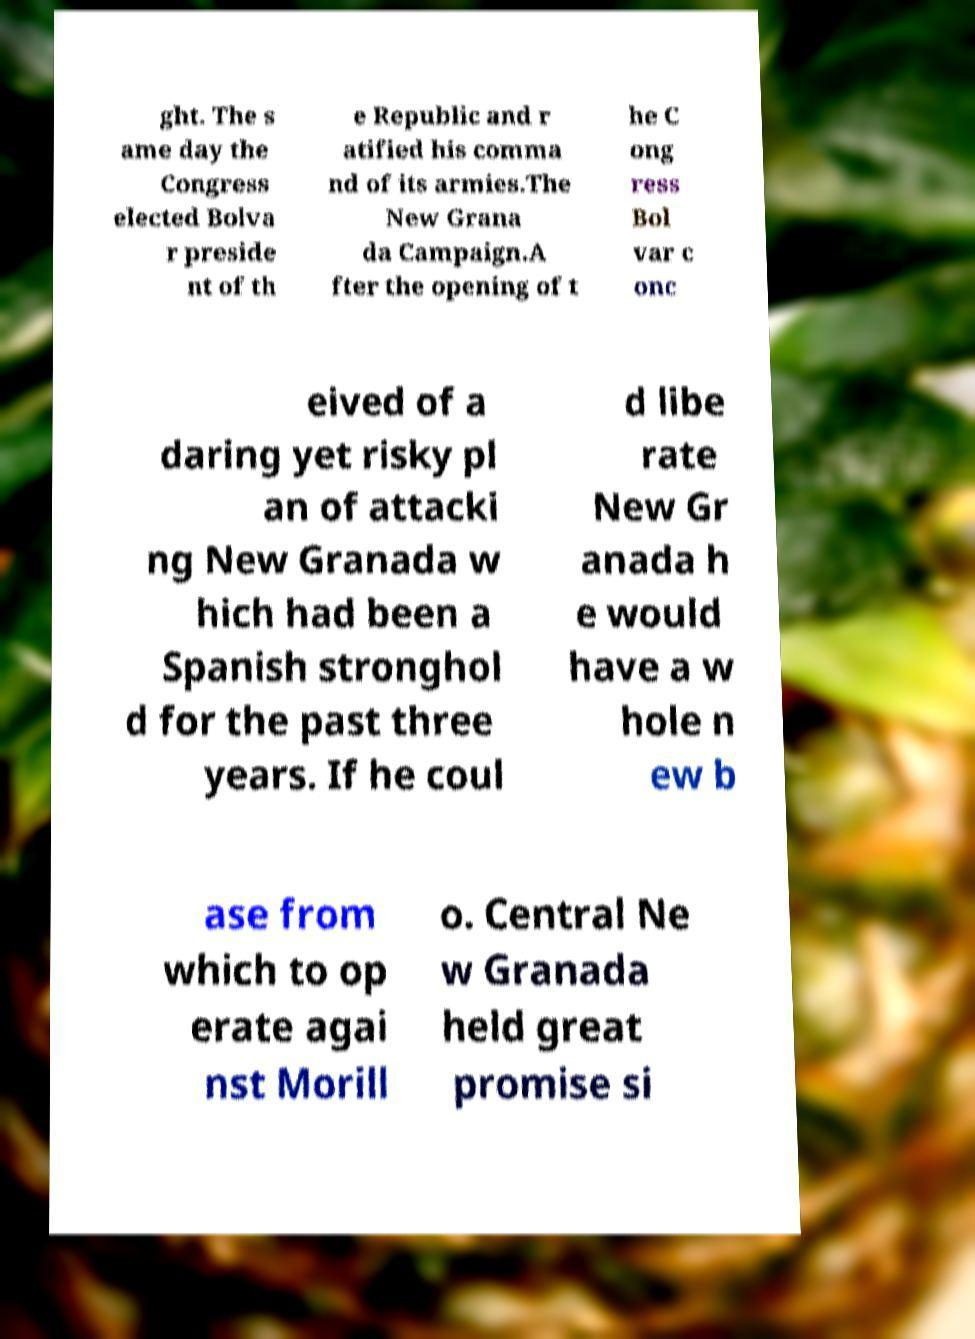For documentation purposes, I need the text within this image transcribed. Could you provide that? ght. The s ame day the Congress elected Bolva r preside nt of th e Republic and r atified his comma nd of its armies.The New Grana da Campaign.A fter the opening of t he C ong ress Bol var c onc eived of a daring yet risky pl an of attacki ng New Granada w hich had been a Spanish stronghol d for the past three years. If he coul d libe rate New Gr anada h e would have a w hole n ew b ase from which to op erate agai nst Morill o. Central Ne w Granada held great promise si 